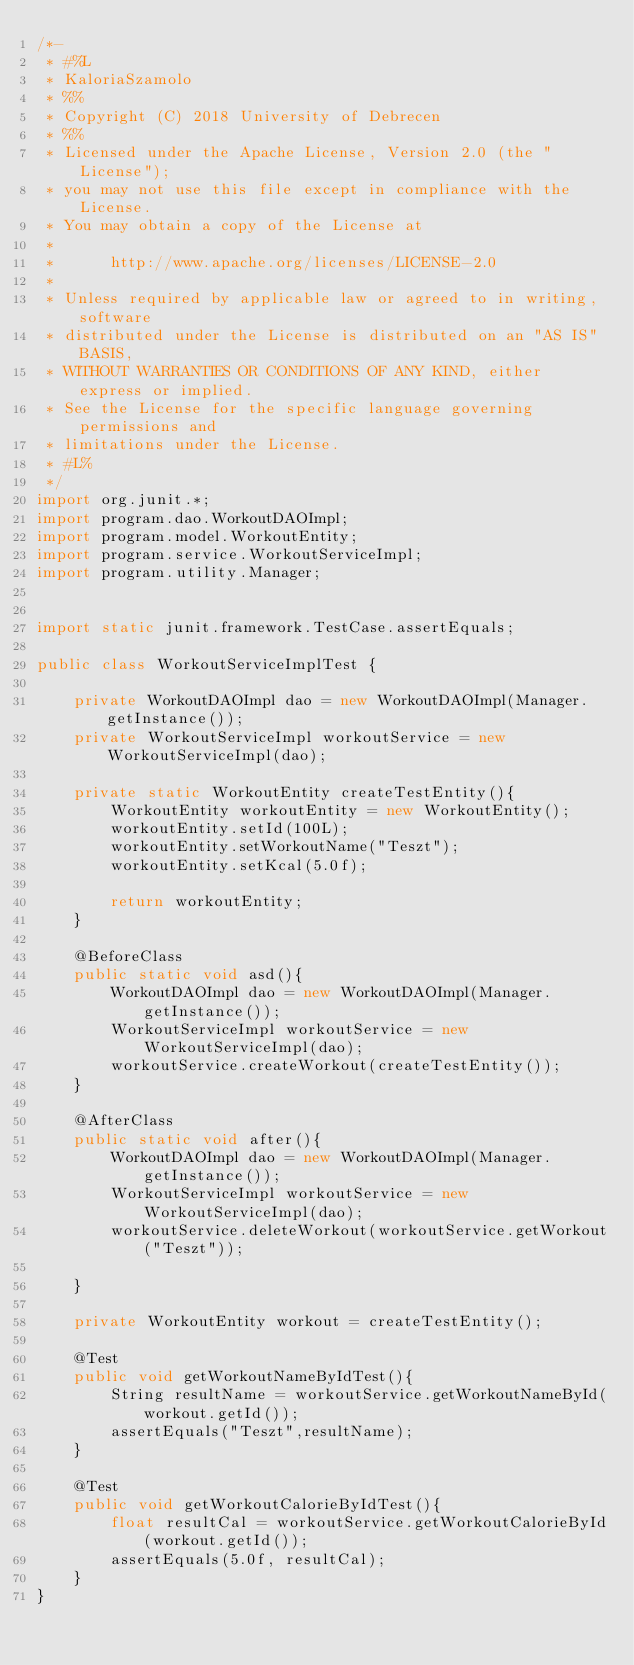<code> <loc_0><loc_0><loc_500><loc_500><_Java_>/*-
 * #%L
 * KaloriaSzamolo
 * %%
 * Copyright (C) 2018 University of Debrecen
 * %%
 * Licensed under the Apache License, Version 2.0 (the "License");
 * you may not use this file except in compliance with the License.
 * You may obtain a copy of the License at
 * 
 *      http://www.apache.org/licenses/LICENSE-2.0
 * 
 * Unless required by applicable law or agreed to in writing, software
 * distributed under the License is distributed on an "AS IS" BASIS,
 * WITHOUT WARRANTIES OR CONDITIONS OF ANY KIND, either express or implied.
 * See the License for the specific language governing permissions and
 * limitations under the License.
 * #L%
 */
import org.junit.*;
import program.dao.WorkoutDAOImpl;
import program.model.WorkoutEntity;
import program.service.WorkoutServiceImpl;
import program.utility.Manager;


import static junit.framework.TestCase.assertEquals;

public class WorkoutServiceImplTest {

    private WorkoutDAOImpl dao = new WorkoutDAOImpl(Manager.getInstance());
    private WorkoutServiceImpl workoutService = new WorkoutServiceImpl(dao);

    private static WorkoutEntity createTestEntity(){
        WorkoutEntity workoutEntity = new WorkoutEntity();
        workoutEntity.setId(100L);
        workoutEntity.setWorkoutName("Teszt");
        workoutEntity.setKcal(5.0f);

        return workoutEntity;
    }

    @BeforeClass
    public static void asd(){
        WorkoutDAOImpl dao = new WorkoutDAOImpl(Manager.getInstance());
        WorkoutServiceImpl workoutService = new WorkoutServiceImpl(dao);
        workoutService.createWorkout(createTestEntity());
    }

    @AfterClass
    public static void after(){
        WorkoutDAOImpl dao = new WorkoutDAOImpl(Manager.getInstance());
        WorkoutServiceImpl workoutService = new WorkoutServiceImpl(dao);
        workoutService.deleteWorkout(workoutService.getWorkout("Teszt"));

    }

    private WorkoutEntity workout = createTestEntity();

    @Test
    public void getWorkoutNameByIdTest(){
        String resultName = workoutService.getWorkoutNameById(workout.getId());
        assertEquals("Teszt",resultName);
    }

    @Test
    public void getWorkoutCalorieByIdTest(){
        float resultCal = workoutService.getWorkoutCalorieById(workout.getId());
        assertEquals(5.0f, resultCal);
    }
}
</code> 